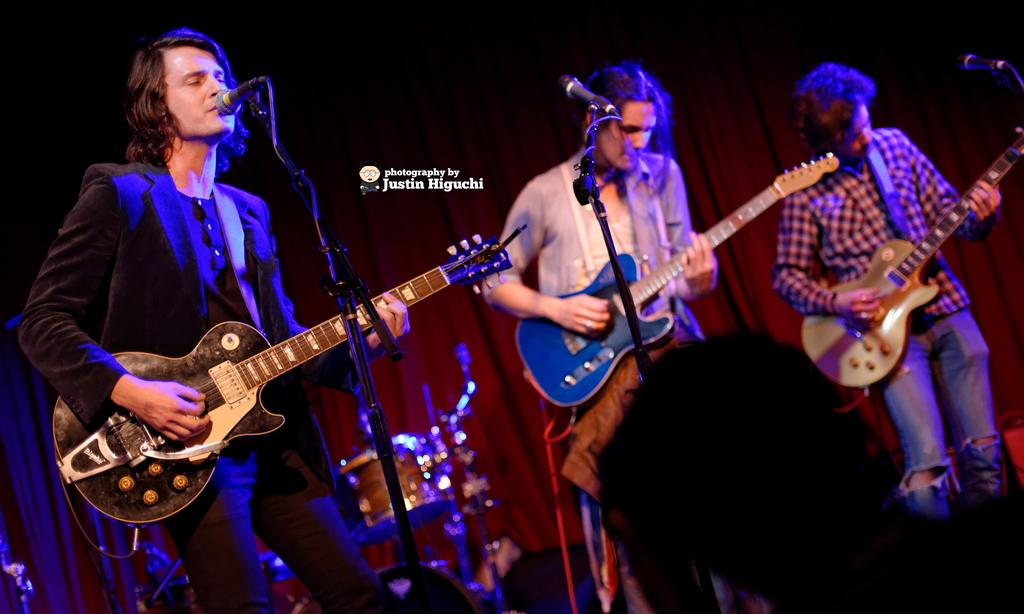How many people are in the image? There are three people in the image. What are the people doing in the image? The people are playing guitars. What other musical instrument can be seen in the image? There is a drum in the image. What object is used for amplifying sound in the image? There is a microphone in the image. What color is the curtain in the background of the image? The curtain in the background of the image is red. How many bottles are visible on the stage in the image? There are no bottles visible on the stage in the image. What type of hands are playing the guitars in the image? The image does not specify the type of hands playing the guitars; it only shows people playing guitars. 